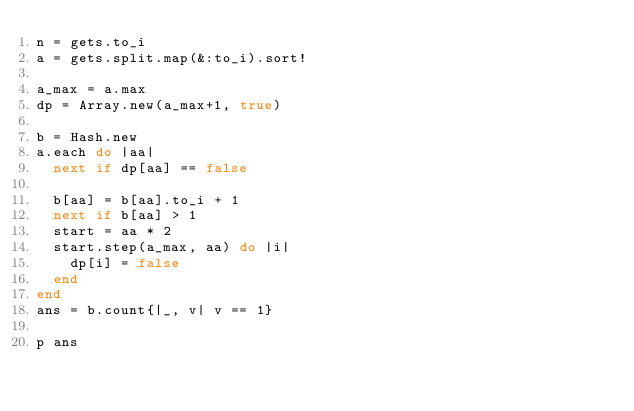Convert code to text. <code><loc_0><loc_0><loc_500><loc_500><_Ruby_>n = gets.to_i
a = gets.split.map(&:to_i).sort!

a_max = a.max
dp = Array.new(a_max+1, true)

b = Hash.new
a.each do |aa|
  next if dp[aa] == false

  b[aa] = b[aa].to_i + 1
  next if b[aa] > 1
  start = aa * 2
  start.step(a_max, aa) do |i|
    dp[i] = false
  end
end
ans = b.count{|_, v| v == 1}

p ans</code> 